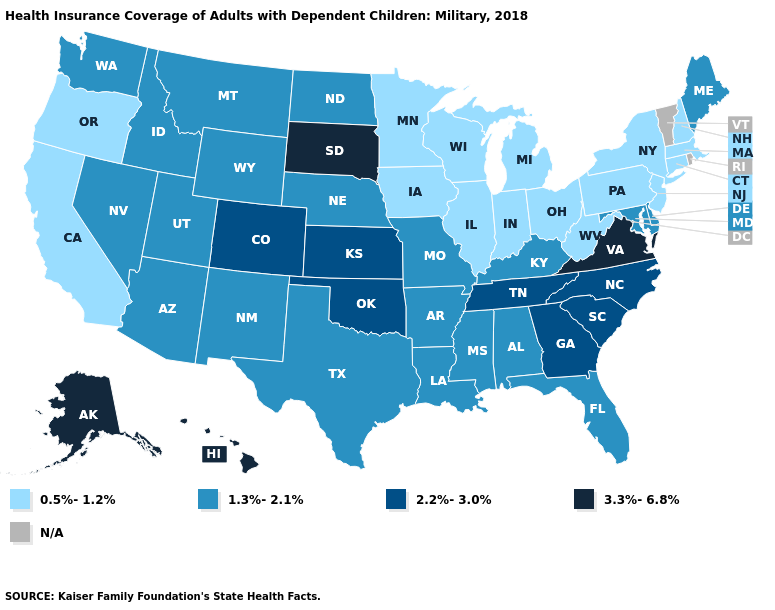Name the states that have a value in the range 2.2%-3.0%?
Answer briefly. Colorado, Georgia, Kansas, North Carolina, Oklahoma, South Carolina, Tennessee. Name the states that have a value in the range 0.5%-1.2%?
Quick response, please. California, Connecticut, Illinois, Indiana, Iowa, Massachusetts, Michigan, Minnesota, New Hampshire, New Jersey, New York, Ohio, Oregon, Pennsylvania, West Virginia, Wisconsin. Name the states that have a value in the range N/A?
Concise answer only. Rhode Island, Vermont. Does the map have missing data?
Quick response, please. Yes. Name the states that have a value in the range 0.5%-1.2%?
Answer briefly. California, Connecticut, Illinois, Indiana, Iowa, Massachusetts, Michigan, Minnesota, New Hampshire, New Jersey, New York, Ohio, Oregon, Pennsylvania, West Virginia, Wisconsin. What is the lowest value in states that border Arkansas?
Keep it brief. 1.3%-2.1%. What is the lowest value in states that border Oregon?
Keep it brief. 0.5%-1.2%. Among the states that border New Jersey , which have the lowest value?
Answer briefly. New York, Pennsylvania. Name the states that have a value in the range 2.2%-3.0%?
Give a very brief answer. Colorado, Georgia, Kansas, North Carolina, Oklahoma, South Carolina, Tennessee. What is the highest value in states that border Delaware?
Answer briefly. 1.3%-2.1%. What is the value of Nebraska?
Write a very short answer. 1.3%-2.1%. Name the states that have a value in the range N/A?
Short answer required. Rhode Island, Vermont. Name the states that have a value in the range 3.3%-6.8%?
Quick response, please. Alaska, Hawaii, South Dakota, Virginia. 